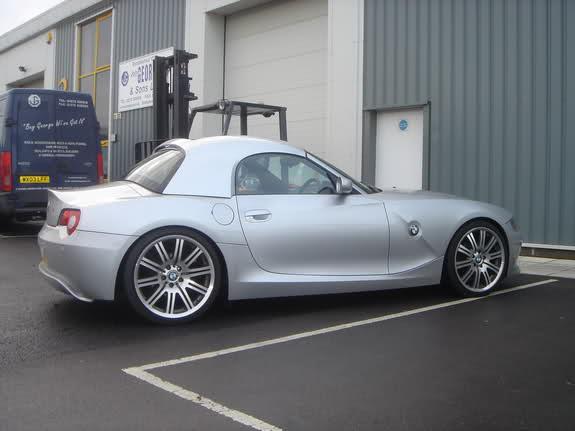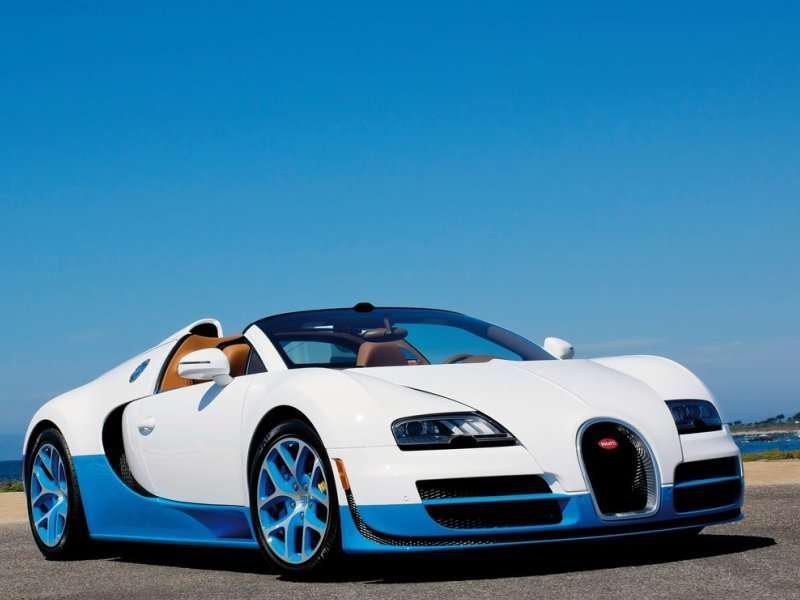The first image is the image on the left, the second image is the image on the right. Analyze the images presented: Is the assertion "In one image, a blue car is shown with its hard roof being lowered into the trunk area." valid? Answer yes or no. No. 